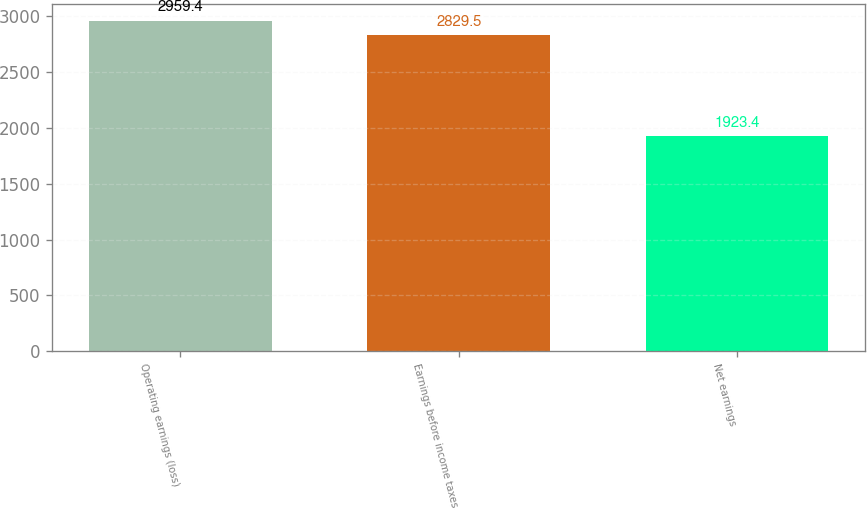<chart> <loc_0><loc_0><loc_500><loc_500><bar_chart><fcel>Operating earnings (loss)<fcel>Earnings before income taxes<fcel>Net earnings<nl><fcel>2959.4<fcel>2829.5<fcel>1923.4<nl></chart> 